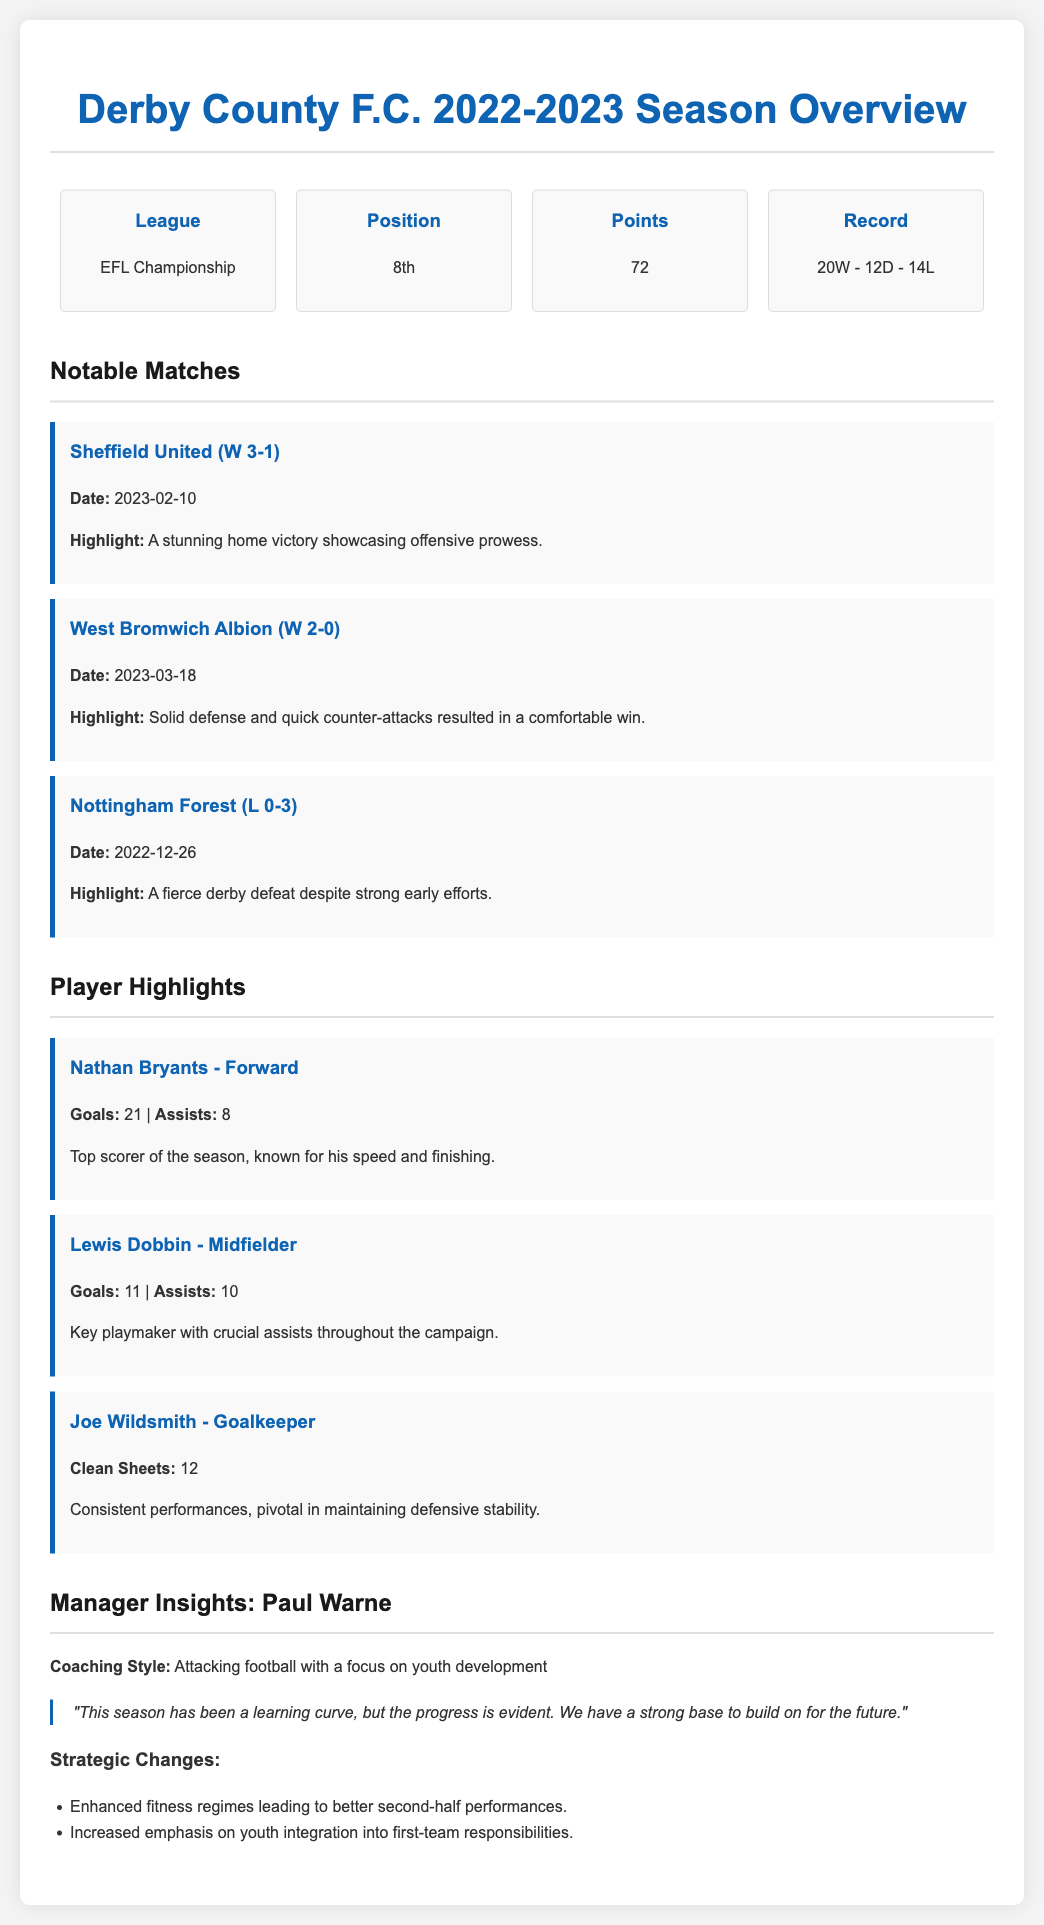What position did Derby County F.C. finish in the league? The document states that Derby County F.C. finished in 8th position in the league.
Answer: 8th How many points did Derby County F.C. accumulate this season? The total points accumulated by Derby County F.C. is mentioned as 72 points in the document.
Answer: 72 Who was the top scorer for Derby County F.C. this season? The document highlights Nathan Bryants as the top scorer with his goals mentioned.
Answer: Nathan Bryants What was the win-loss record for Derby County F.C. this season? The record is clearly outlined in the document as 20 wins, 12 draws, and 14 losses.
Answer: 20W - 12D - 14L What was a notable match where Derby County F.C. achieved a victory, including the scoreline? The document mentions a notable match against Sheffield United with a scoreline of 3-1 in favor of Derby County F.C.
Answer: Sheffield United (W 3-1) What was the coaching style of Paul Warne? The document specifies that Paul Warne's coaching style focuses on attacking football and youth development.
Answer: Attacking football with a focus on youth development How many clean sheets did Joe Wildsmith record this season? The document states that Joe Wildsmith recorded 12 clean sheets during the season.
Answer: 12 On what date did Derby County F.C. lose to Nottingham Forest? The document cites the date of the match against Nottingham Forest as December 26, 2022.
Answer: 2022-12-26 What was the highlight of the match against West Bromwich Albion? The document describes the highlight of the match as solid defense and quick counter-attacks leading to a comfortable win.
Answer: Solid defense and quick counter-attacks 